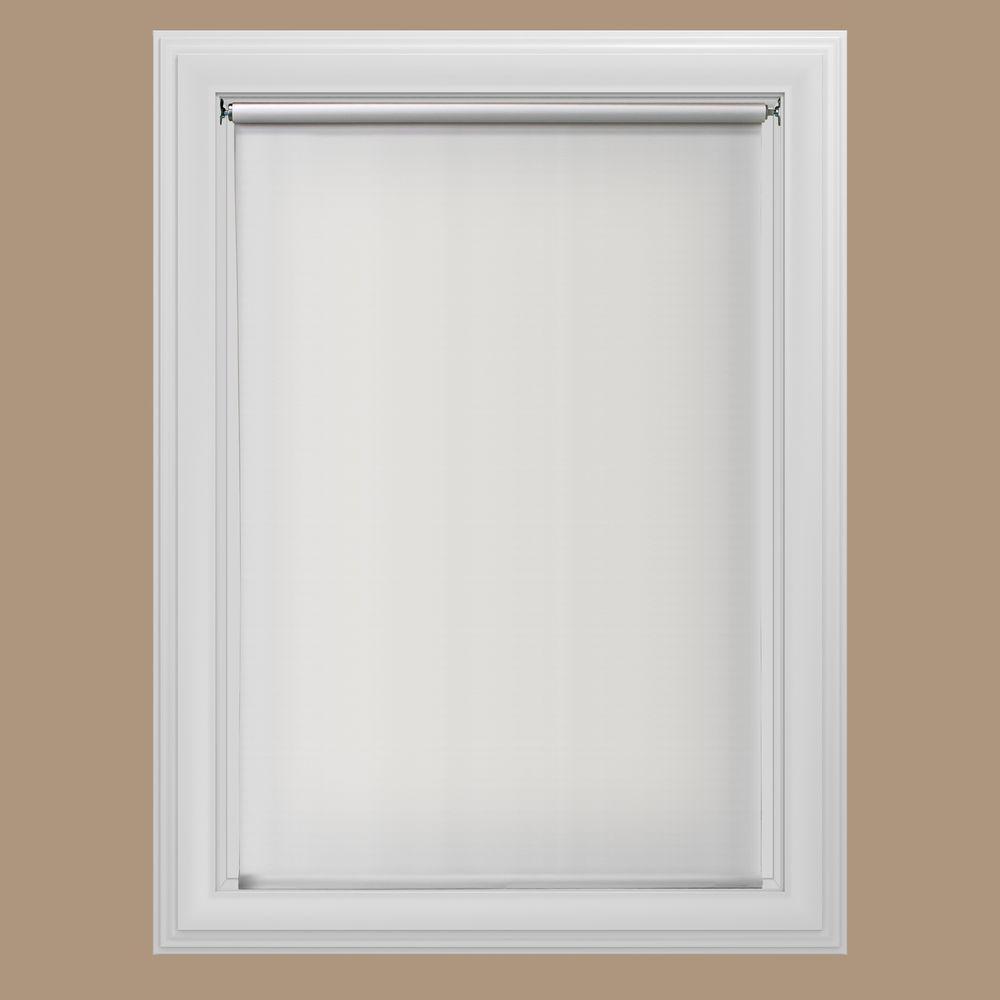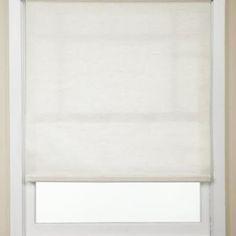The first image is the image on the left, the second image is the image on the right. For the images displayed, is the sentence "The left and right image contains the same number of blinds." factually correct? Answer yes or no. Yes. The first image is the image on the left, the second image is the image on the right. Considering the images on both sides, is "There are a total of two windows with white frames shown." valid? Answer yes or no. Yes. 